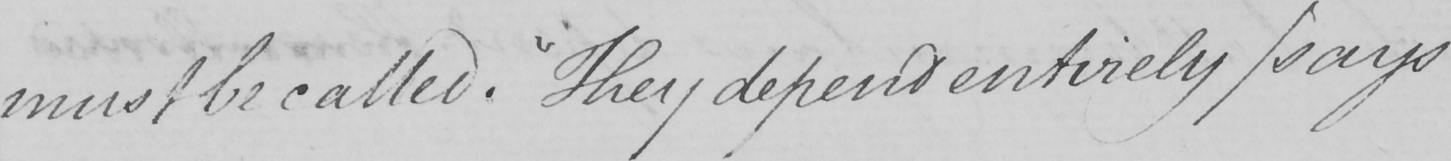What is written in this line of handwriting? must be called .  " They depend entirely  ( says 